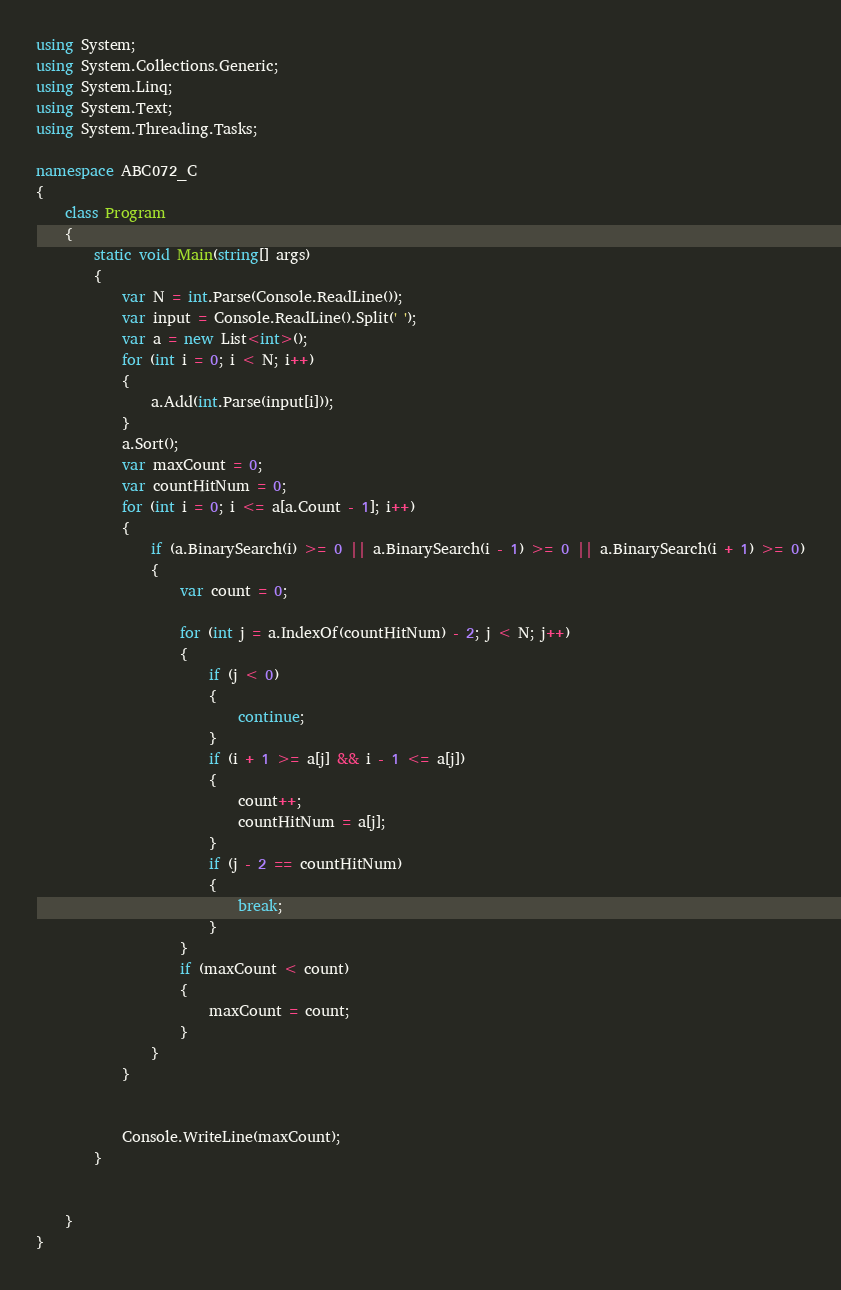<code> <loc_0><loc_0><loc_500><loc_500><_C#_>using System;
using System.Collections.Generic;
using System.Linq;
using System.Text;
using System.Threading.Tasks;

namespace ABC072_C
{
    class Program
    {
        static void Main(string[] args)
        {
            var N = int.Parse(Console.ReadLine());
            var input = Console.ReadLine().Split(' ');
            var a = new List<int>();
            for (int i = 0; i < N; i++)
            {
                a.Add(int.Parse(input[i]));
            }
            a.Sort();
            var maxCount = 0;
            var countHitNum = 0;
            for (int i = 0; i <= a[a.Count - 1]; i++)
            {
                if (a.BinarySearch(i) >= 0 || a.BinarySearch(i - 1) >= 0 || a.BinarySearch(i + 1) >= 0)
                {
                    var count = 0;
                    
                    for (int j = a.IndexOf(countHitNum) - 2; j < N; j++)
                    {
                        if (j < 0)
                        {
                            continue;
                        }
                        if (i + 1 >= a[j] && i - 1 <= a[j])
                        {
                            count++;
                            countHitNum = a[j];
                        }
                        if (j - 2 == countHitNum)
                        {
                            break;
                        }
                    }
                    if (maxCount < count)
                    {
                        maxCount = count;
                    }
                }
            }


            Console.WriteLine(maxCount);
        }


    }
}
</code> 